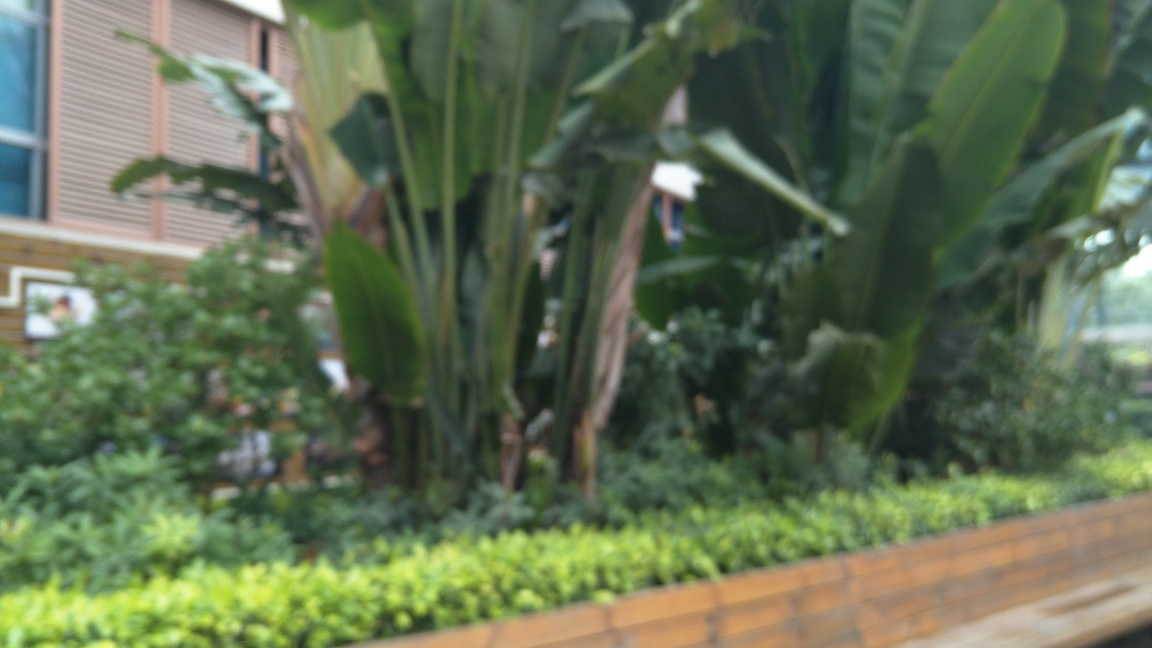This photo seems to have been taken outdoors; can you tell what time of day it might be? While the blurriness makes it difficult to identify specific lighting conditions, we can infer a few details. The natural light and the absence of long shadows or warm hues that are typically associated with sunrise or sunset suggest this photo was likely taken during midday. The well-lit environment and lack of harsh shadow contrasts support this theory. 